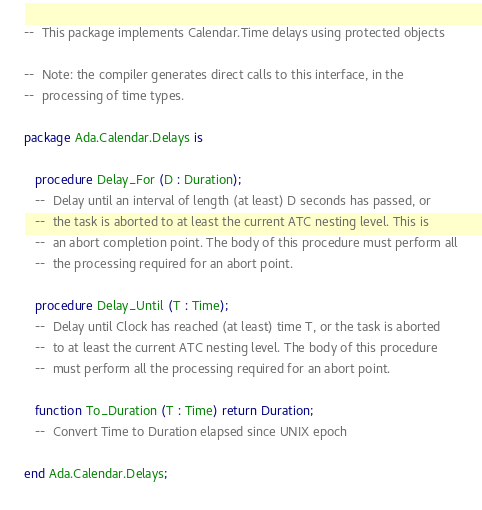Convert code to text. <code><loc_0><loc_0><loc_500><loc_500><_Ada_>--  This package implements Calendar.Time delays using protected objects

--  Note: the compiler generates direct calls to this interface, in the
--  processing of time types.

package Ada.Calendar.Delays is

   procedure Delay_For (D : Duration);
   --  Delay until an interval of length (at least) D seconds has passed, or
   --  the task is aborted to at least the current ATC nesting level. This is
   --  an abort completion point. The body of this procedure must perform all
   --  the processing required for an abort point.

   procedure Delay_Until (T : Time);
   --  Delay until Clock has reached (at least) time T, or the task is aborted
   --  to at least the current ATC nesting level. The body of this procedure
   --  must perform all the processing required for an abort point.

   function To_Duration (T : Time) return Duration;
   --  Convert Time to Duration elapsed since UNIX epoch

end Ada.Calendar.Delays;
</code> 